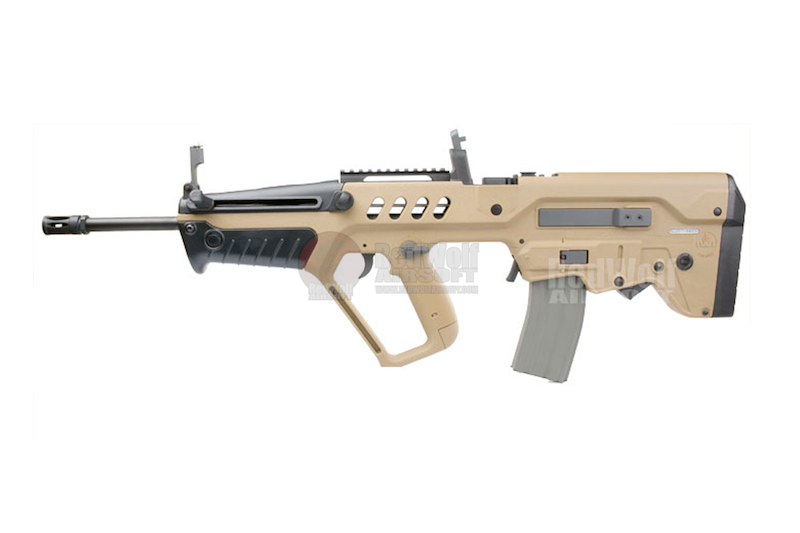Can you describe a scenario where the features of this firearm are particularly advantageous in action? Imagine a special operations team tasked with clearing a series of narrow corridors and cramped rooms in an urban environment. The compact bullpup design of this firearm allows team members to move swiftly and efficiently through tight spaces, while still providing the accuracy needed to engage targets at both close and medium ranges. The integrated iron sights facilitate quick target acquisition in fast-paced scenarios, and the Picatinny rail allows for the attachment of night vision optics, ensuring effectiveness even in low-light conditions. The ergonomic grip ensures the firearm is easy to handle for extended periods, maintaining precision and stability during prolonged engagements. What creative new application could you imagine for this type of firearm outside of conventional military or law enforcement uses? A creative new application for this type of firearm could be in a high-tech, competitive shooting sport that combines physical agility with advanced marksmanship. Imagine a futuristic obstacle course equipped with dynamic targets and varying shooting environments. Competitors would navigate through the course while being timed, using the firearm's precision and compact design to hit targets as they appear. The Picatinny rail system would allow for the attachment of specialized optics and sensors, giving shooters real-time feedback on their accuracy and performance. This blend of physical and technical challenge would create an exciting, engaging sport for both participants and spectators. 